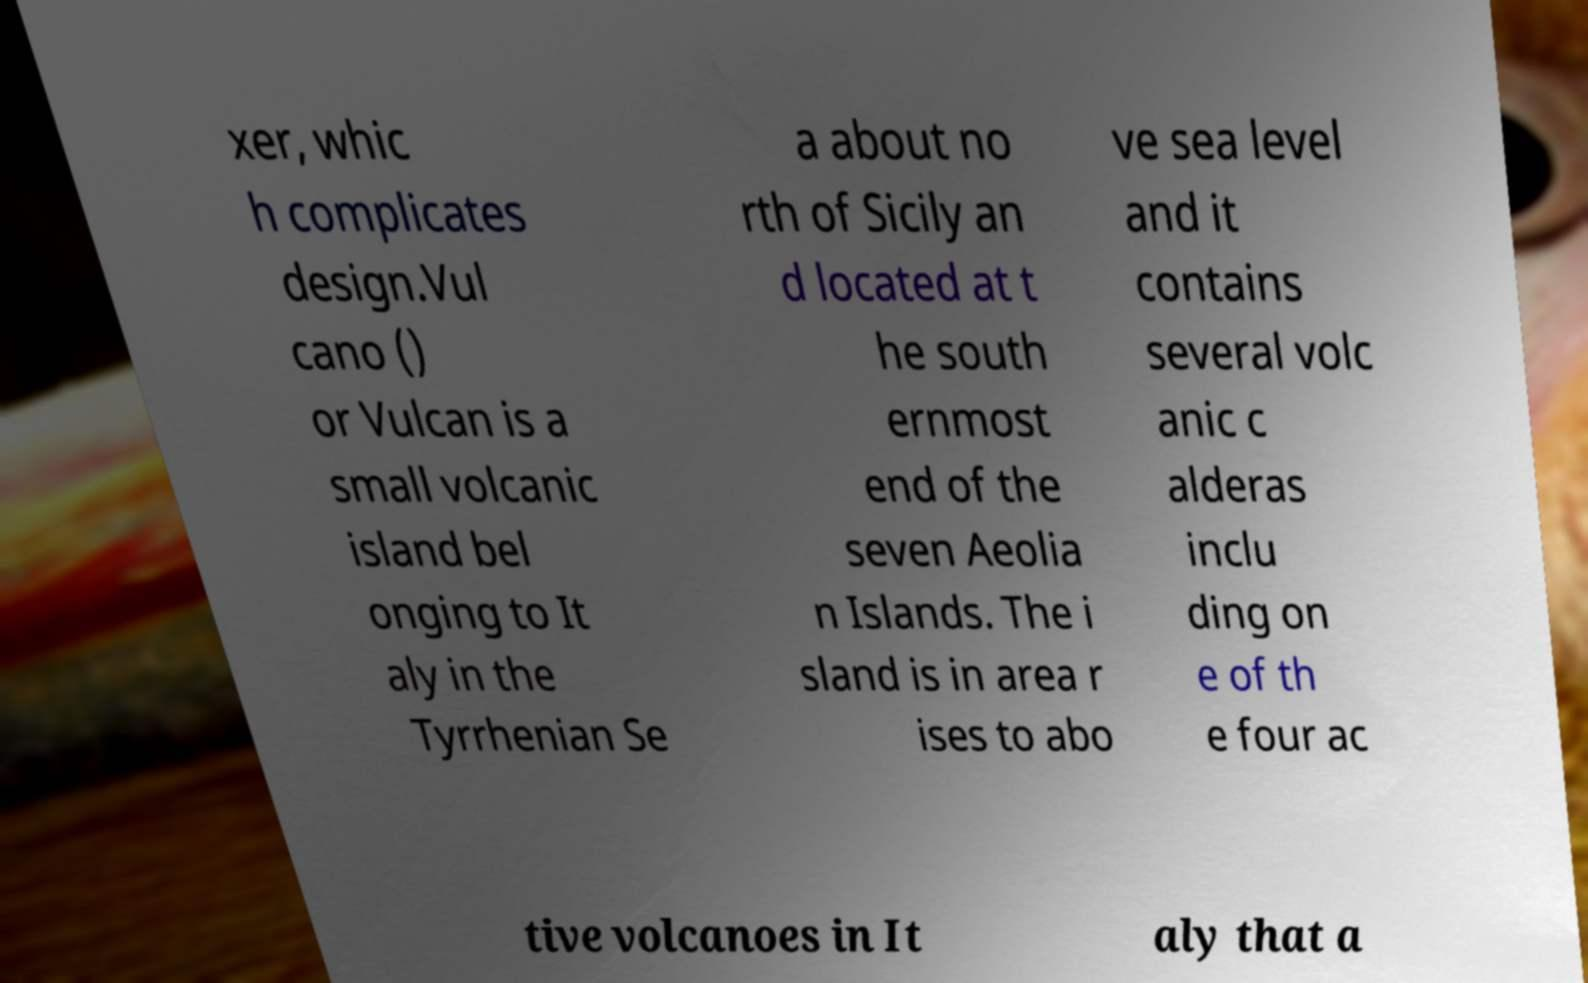There's text embedded in this image that I need extracted. Can you transcribe it verbatim? xer, whic h complicates design.Vul cano () or Vulcan is a small volcanic island bel onging to It aly in the Tyrrhenian Se a about no rth of Sicily an d located at t he south ernmost end of the seven Aeolia n Islands. The i sland is in area r ises to abo ve sea level and it contains several volc anic c alderas inclu ding on e of th e four ac tive volcanoes in It aly that a 